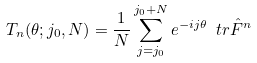<formula> <loc_0><loc_0><loc_500><loc_500>T _ { n } ( \theta ; j _ { 0 } , N ) = \frac { 1 } { N } \sum _ { j = j _ { 0 } } ^ { j _ { 0 } + N } e ^ { - i j \theta } \ t r \hat { F } ^ { n }</formula> 